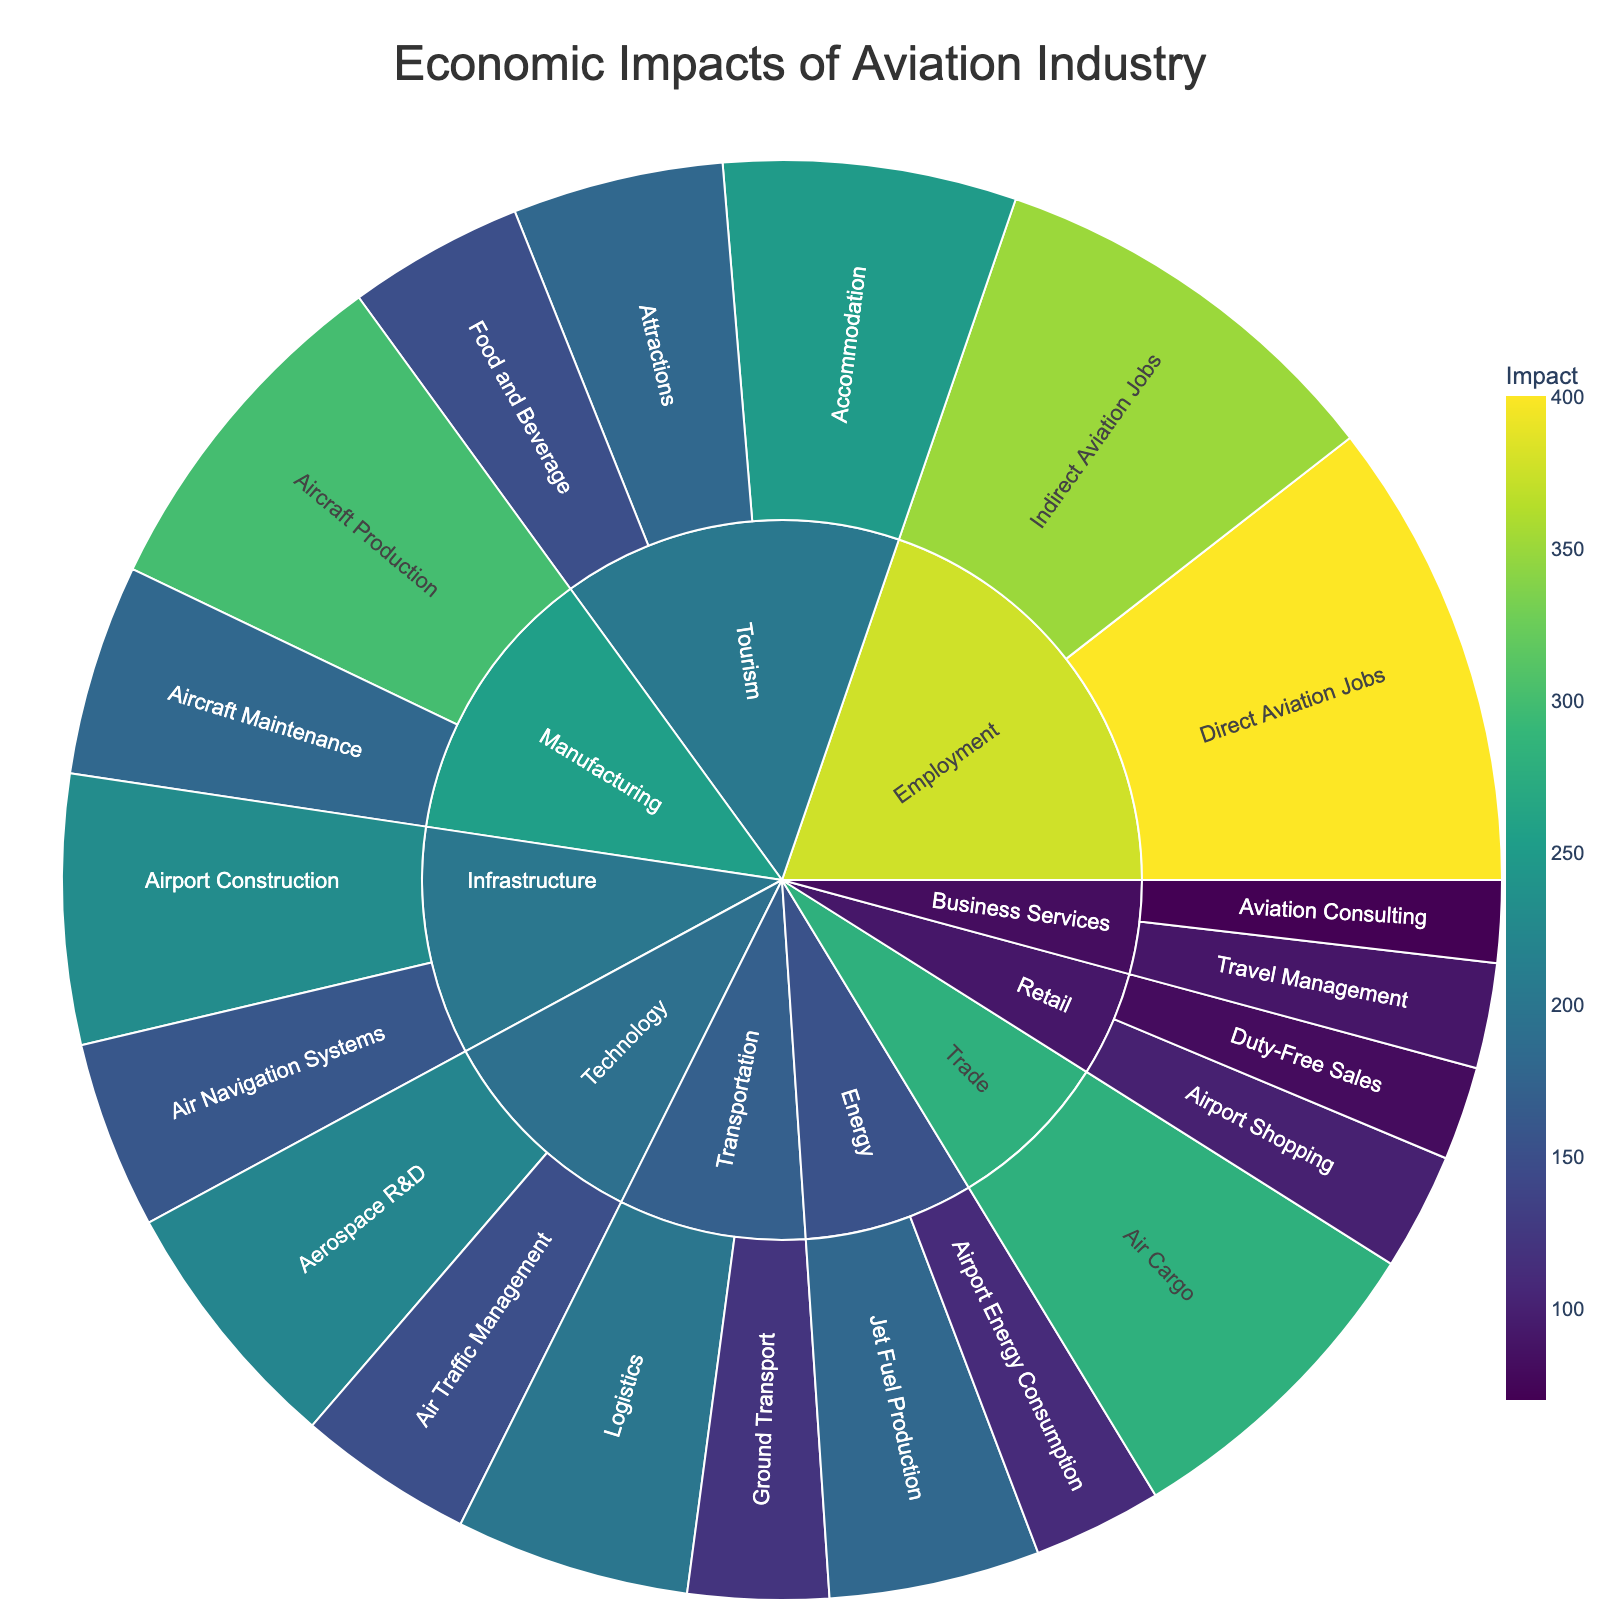What sector has the highest economic impact in aviation? By examining the size of the segments in the Sunburst Plot and the values associated with each sector, we can see which sector has the largest total economic impact. Specifically, we look for the sector with the largest cumulative values for its subsectors.
Answer: Employment How does the impact of Aircraft Production compare to Aerospace R&D? To compare the impact of 'Aircraft Production' and 'Aerospace R&D', we simply find the corresponding segments and their values in the Sunburst Plot. We then observe that Aircraft Production has an impact of 300, while Aerospace R&D has an impact of 220.
Answer: Aircraft Production is higher What is the total impact of the Energy sector? The Energy sector includes 'Jet Fuel Production' (180) and 'Airport Energy Consumption' (110). We sum these values to get the total impact of the Energy sector.
Answer: 290 Which subsector in Tourism has the lowest impact? By examining the subsectors within Tourism in the Sunburst Plot, we compare the values for Accommodation (250), Attractions (180), and Food and Beverage (150). The lowest value among these is for Food and Beverage.
Answer: Food and Beverage What is the combined impact of Direct Aviation Jobs and Indirect Aviation Jobs in the Employment sector? We identify the impact values for 'Direct Aviation Jobs' (400) and 'Indirect Aviation Jobs' (350) in the Employment sector. Summing these values gives us the combined impact.
Answer: 750 Compare the impact of Airport Construction to Aircraft Maintenance. Which one is higher? Looking at the Sunburst Plot, the impact of 'Airport Construction' is 230 and the impact of 'Aircraft Maintenance' is 180. Comparing these two values, we see which one is higher.
Answer: Airport Construction What is the impact difference between Ground Transport and Air Cargo? We find the values for 'Ground Transport' (120) and 'Air Cargo' (280) from the Sunburst Plot. We then calculate the difference by subtracting the lower value from the higher value.
Answer: 160 Which subsector in Retail has a higher impact: Airport Shopping or Duty-Free Sales? We look at the Sunburst Plot for the values of 'Airport Shopping' (100) and 'Duty-Free Sales' (80). The higher value indicates the subsector with the higher impact.
Answer: Airport Shopping Calculate the average impact of all subsectors within the Technology sector. The Technology sector includes 'Aerospace R&D' (220) and 'Air Traffic Management' (150). We sum these values to get a total of 370 and then divide by the number of subsectors (2).
Answer: 185 What is the total economic impact contributed by the Business Services sector? The Business Services sector consists of 'Travel Management' (90) and 'Aviation Consulting' (70). Summing these values gives the total impact.
Answer: 160 